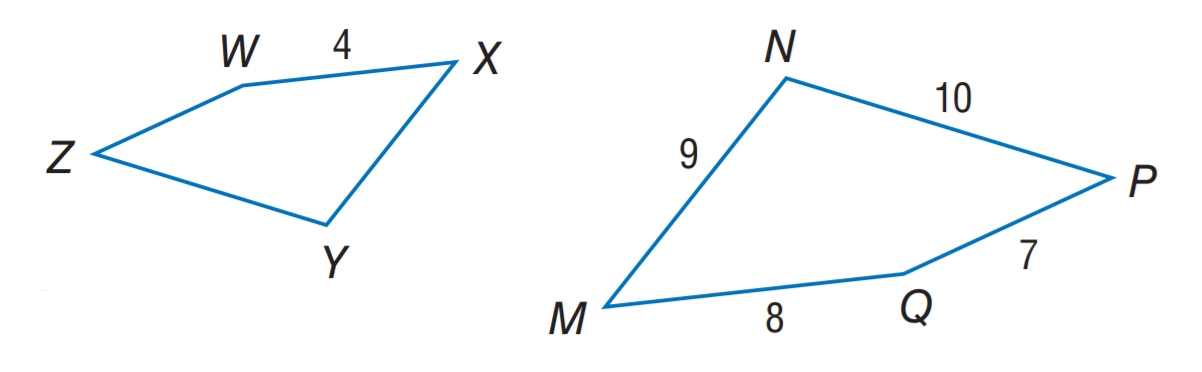Answer the mathemtical geometry problem and directly provide the correct option letter.
Question: If M N P Q \sim X Y Z W, find the perimeter of M N P Q.
Choices: A: 17 B: 18 C: 20 D: 34 D 